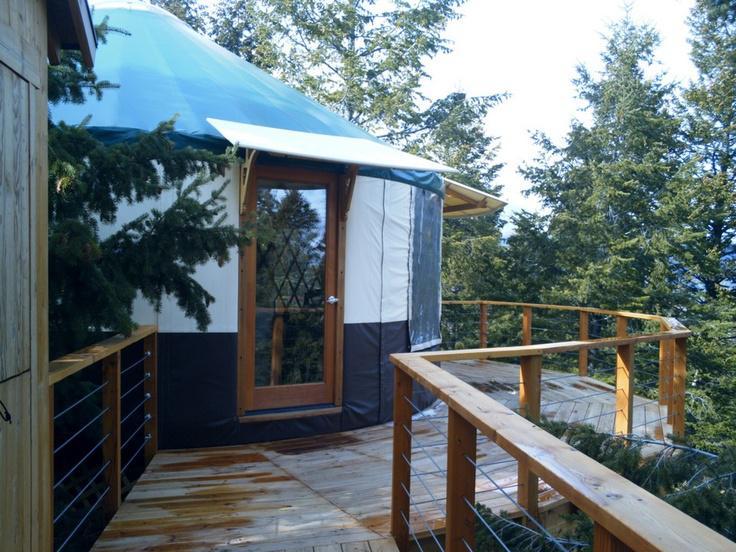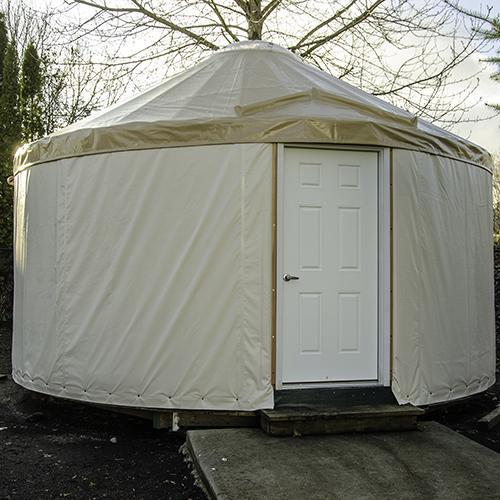The first image is the image on the left, the second image is the image on the right. Considering the images on both sides, is "Left image shows a domed structure with darker top and bottom sections and a wooden railed walkway curving around it." valid? Answer yes or no. Yes. 